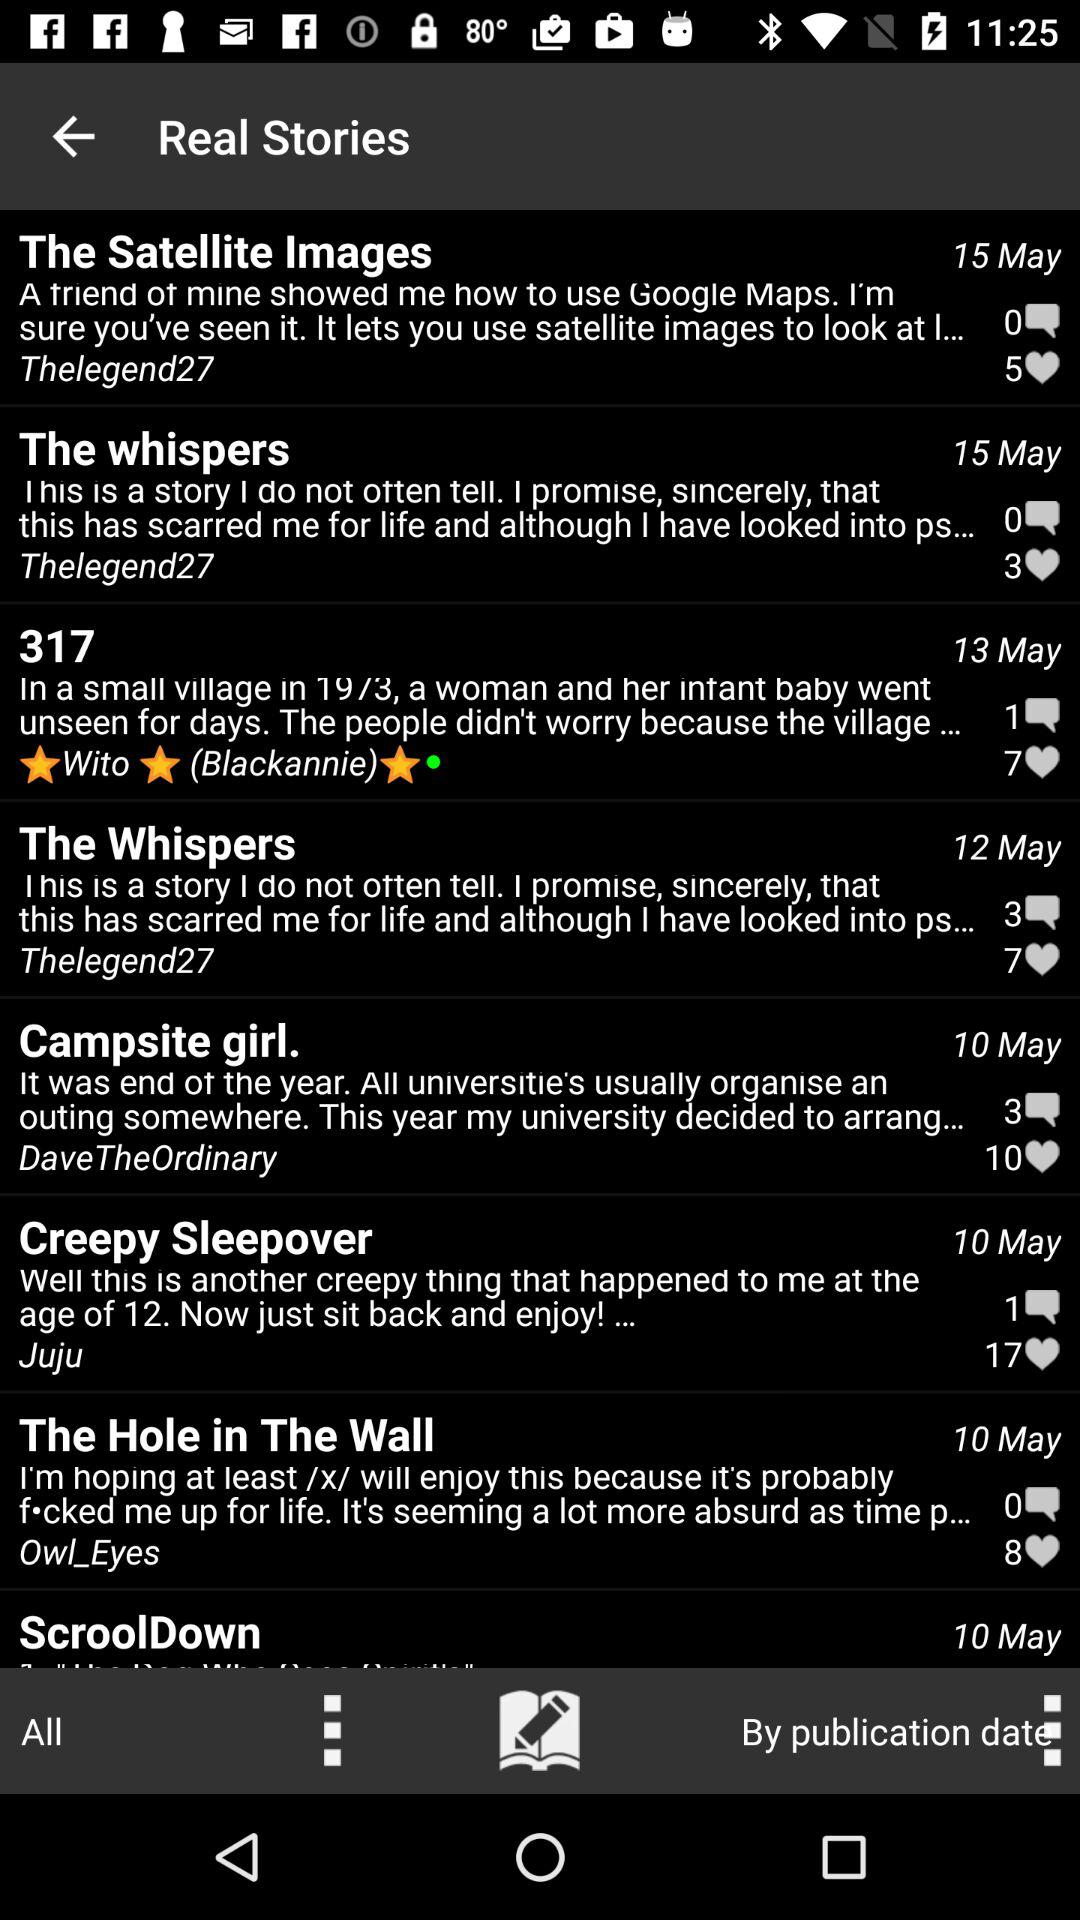What stories were posted on May 10? The stories "Campsite girl.", "Creepy Sleepover", "The Hole in The Wall", and "ScroolDown" were posted on May 10. 